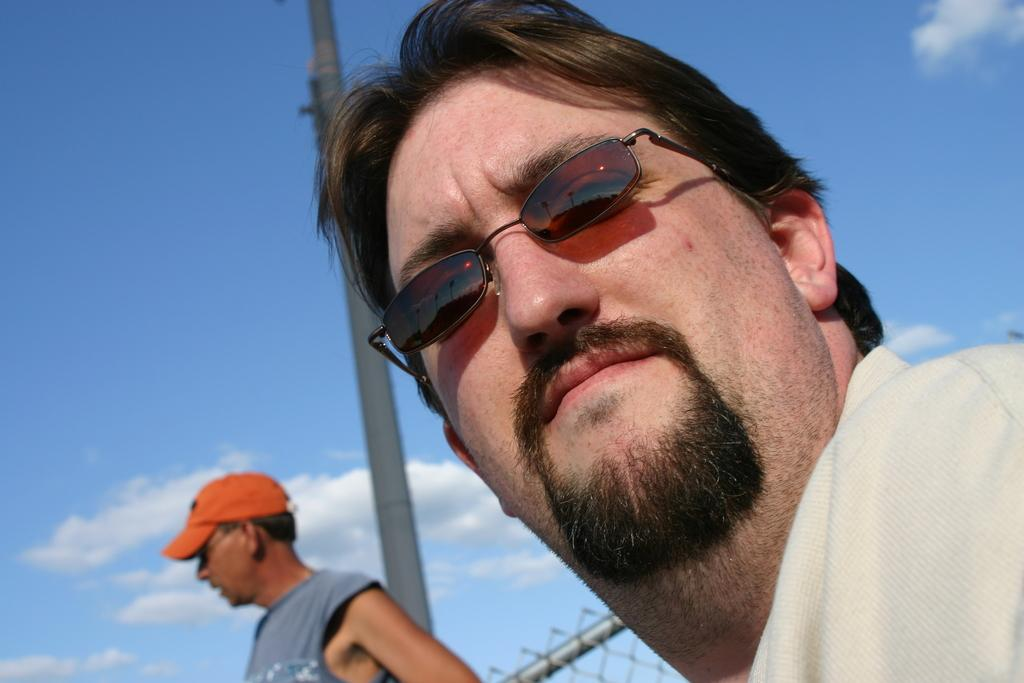How many people are in the image? There are two men in the image. What can be seen in the image besides the men? There is a fence and a pole in the image. What is visible in the background of the image? The sky is visible in the background of the image. What is the condition of the sky in the image? Clouds are present in the sky. Reasoning: Let'g: Let's think step by step in order to produce the conversation. We start by identifying the main subjects in the image, which are the two men. Then, we describe other objects and elements in the image, such as the fence, pole, and sky. We ensure that each question can be answered definitively with the information given and avoid yes/no questions. Absurd Question/Answer: What type of apple is being used to power the pole in the image? There is no apple present in the image, and the pole is not powered by an apple. 